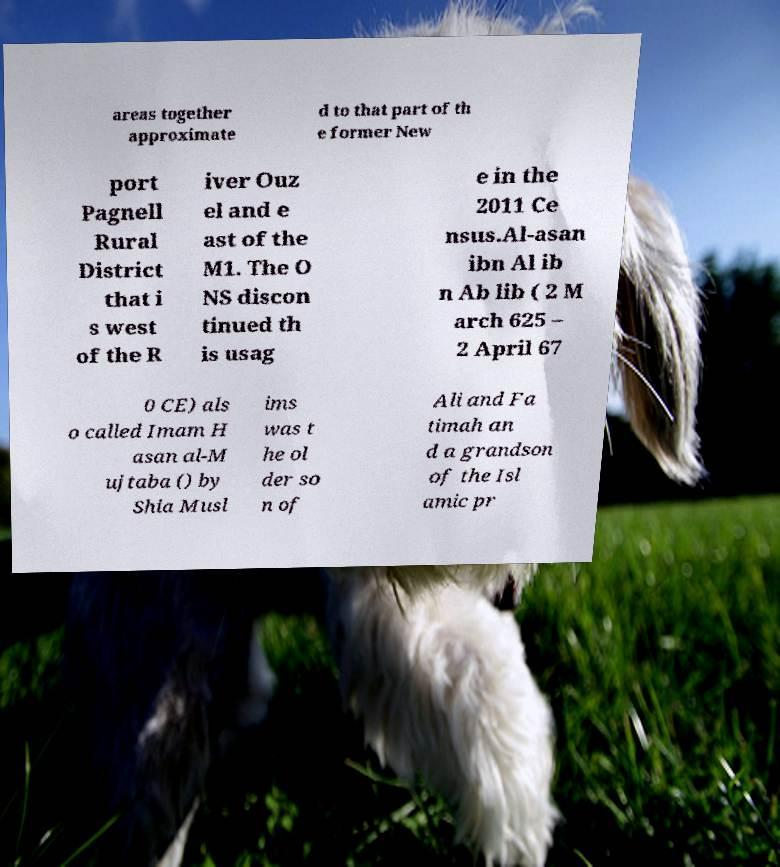There's text embedded in this image that I need extracted. Can you transcribe it verbatim? areas together approximate d to that part of th e former New port Pagnell Rural District that i s west of the R iver Ouz el and e ast of the M1. The O NS discon tinued th is usag e in the 2011 Ce nsus.Al-asan ibn Al ib n Ab lib ( 2 M arch 625 – 2 April 67 0 CE) als o called Imam H asan al-M ujtaba () by Shia Musl ims was t he ol der so n of Ali and Fa timah an d a grandson of the Isl amic pr 